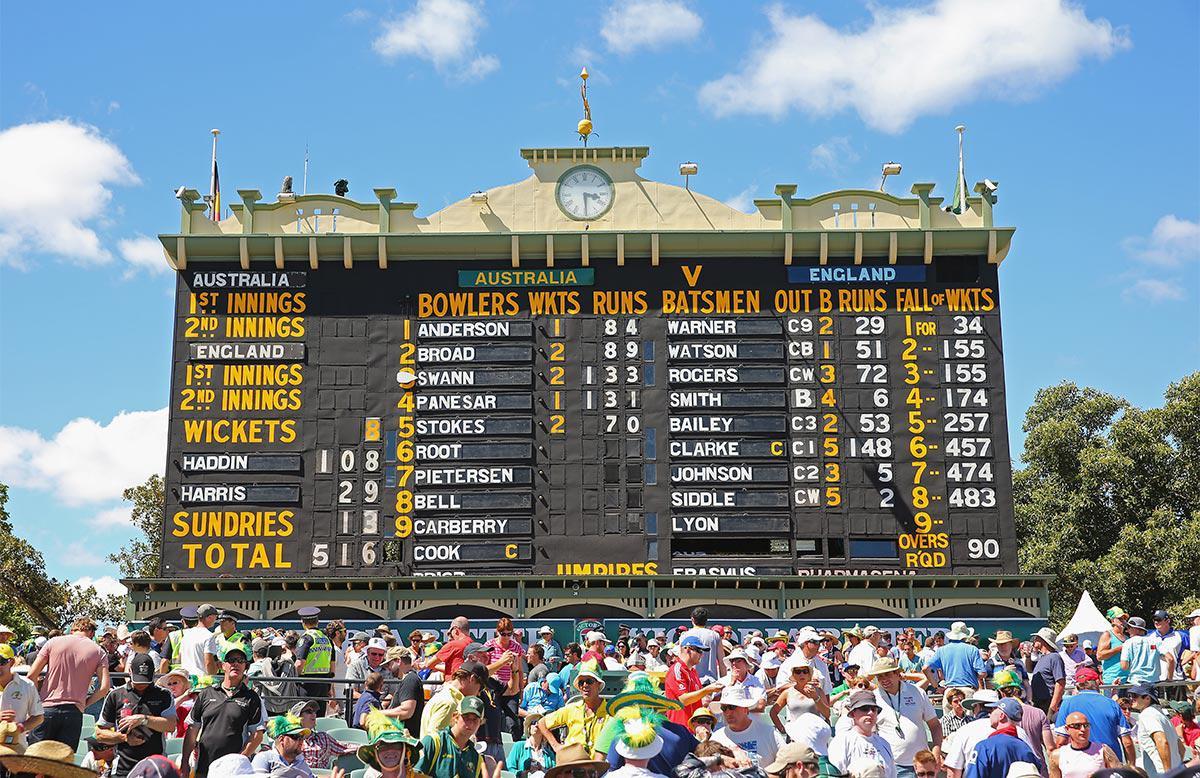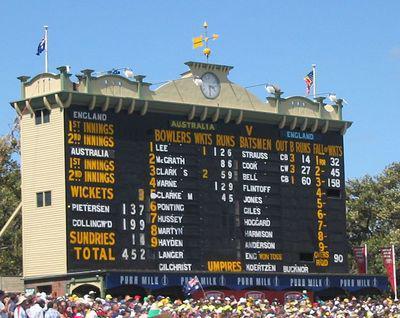The first image is the image on the left, the second image is the image on the right. Given the left and right images, does the statement "A blue advertisement sits beneath the scoreboard in the image on the left." hold true? Answer yes or no. No. 